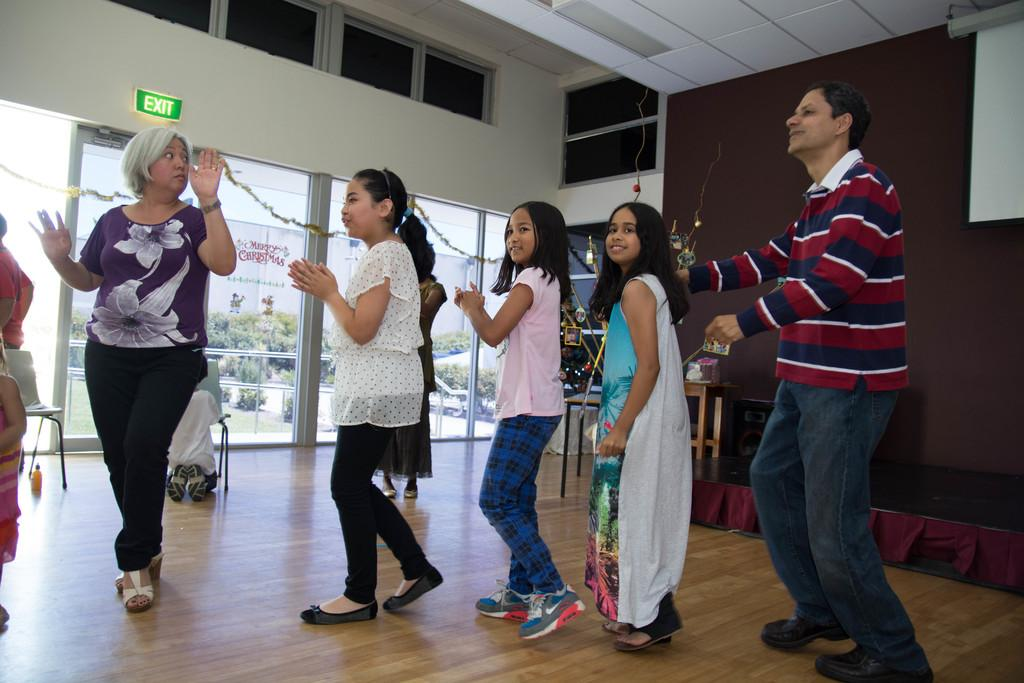What are the people in the image doing? The people in the image are dancing. What furniture can be seen in the image? There is a table and chairs in the image. What is on the table in the image? There are objects on the table. What architectural features are present in the image? There are glass windows and doors in the image. What type of vegetation is visible in the image? There are trees and plants in the image. How does the steel breathe in the image? There is no steel present in the image, and therefore it cannot breathe. 